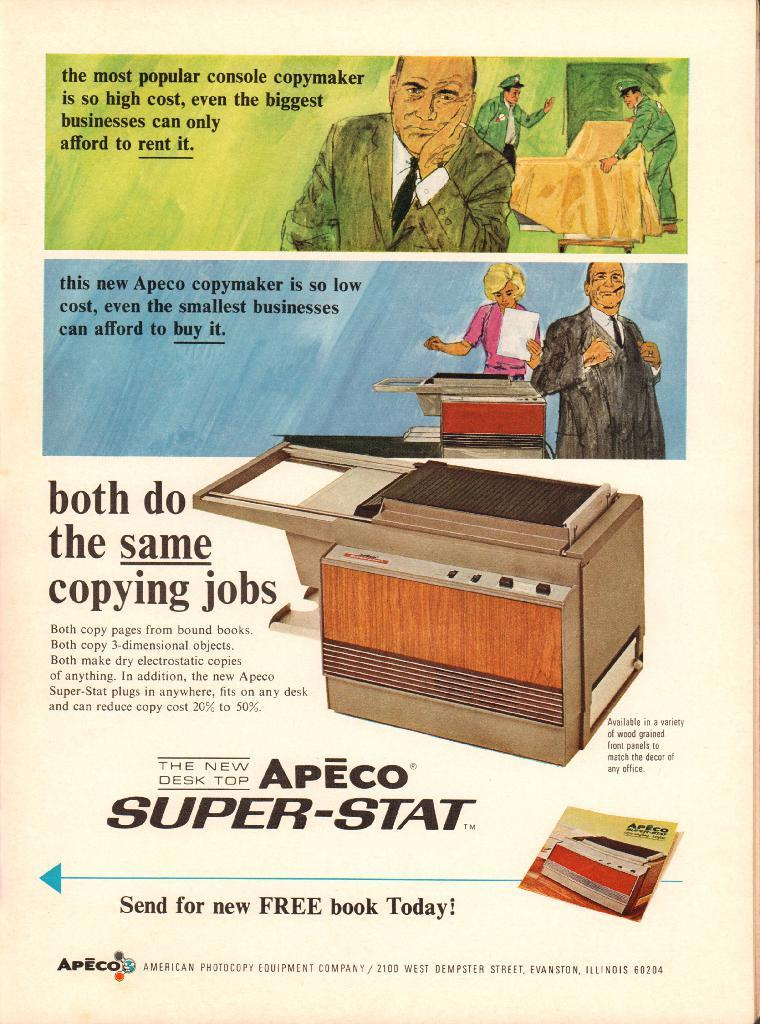<image>
Describe the image concisely. a paper that says 'apeco super-stat' on it in black 